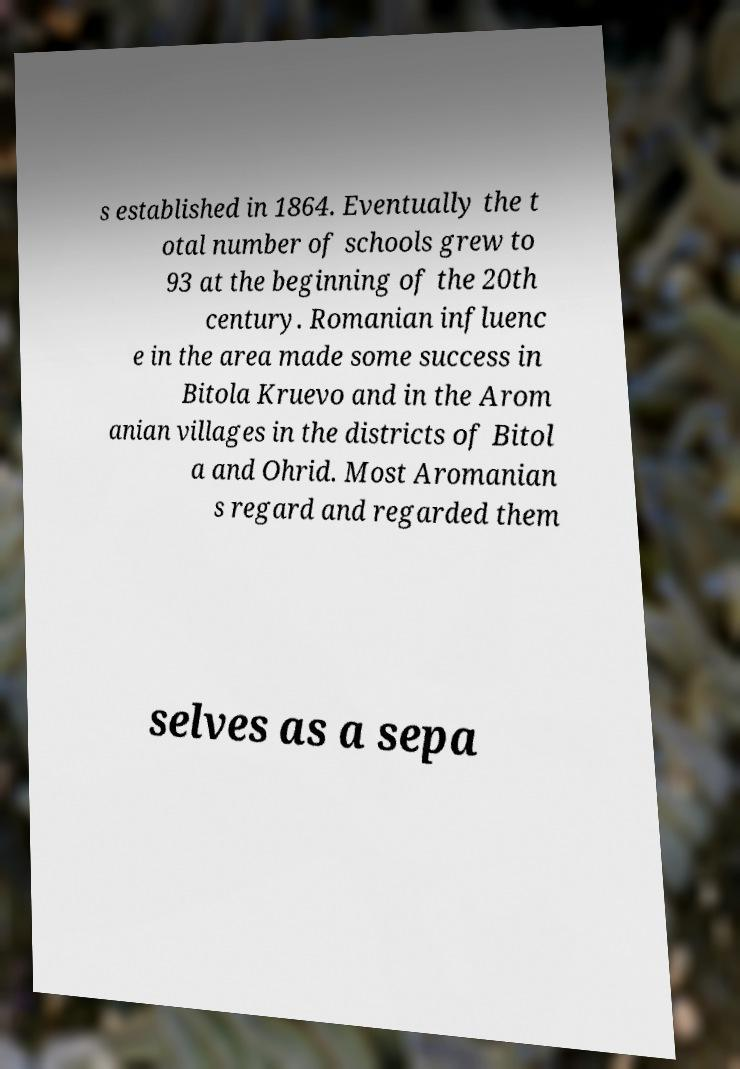Can you read and provide the text displayed in the image?This photo seems to have some interesting text. Can you extract and type it out for me? s established in 1864. Eventually the t otal number of schools grew to 93 at the beginning of the 20th century. Romanian influenc e in the area made some success in Bitola Kruevo and in the Arom anian villages in the districts of Bitol a and Ohrid. Most Aromanian s regard and regarded them selves as a sepa 